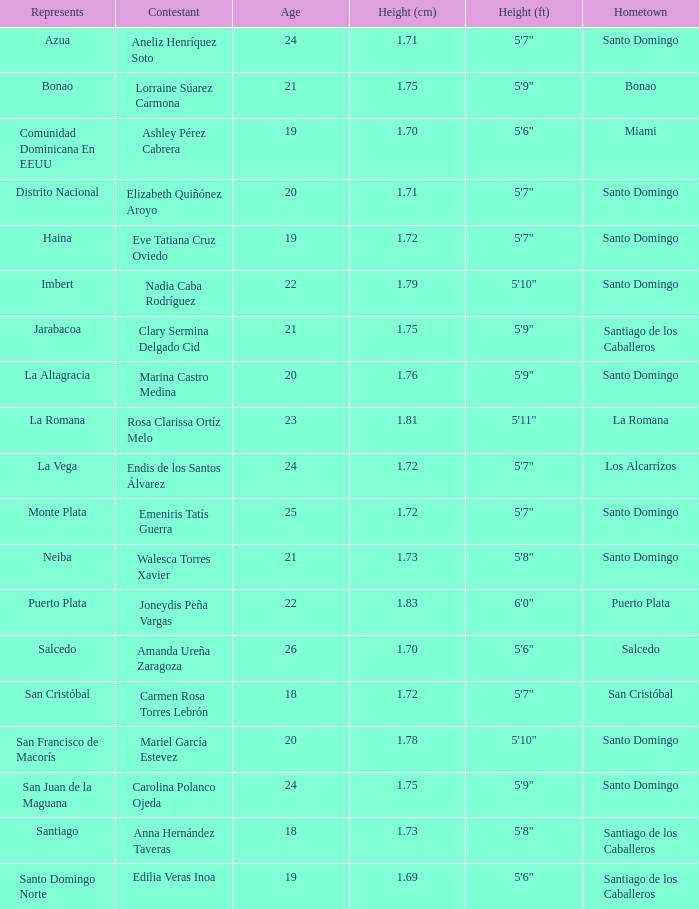Give me the full table as a dictionary. {'header': ['Represents', 'Contestant', 'Age', 'Height (cm)', 'Height (ft)', 'Hometown'], 'rows': [['Azua', 'Aneliz Henríquez Soto', '24', '1.71', '5\'7"', 'Santo Domingo'], ['Bonao', 'Lorraine Súarez Carmona', '21', '1.75', '5\'9"', 'Bonao'], ['Comunidad Dominicana En EEUU', 'Ashley Pérez Cabrera', '19', '1.70', '5\'6"', 'Miami'], ['Distrito Nacional', 'Elizabeth Quiñónez Aroyo', '20', '1.71', '5\'7"', 'Santo Domingo'], ['Haina', 'Eve Tatiana Cruz Oviedo', '19', '1.72', '5\'7"', 'Santo Domingo'], ['Imbert', 'Nadia Caba Rodríguez', '22', '1.79', '5\'10"', 'Santo Domingo'], ['Jarabacoa', 'Clary Sermina Delgado Cid', '21', '1.75', '5\'9"', 'Santiago de los Caballeros'], ['La Altagracia', 'Marina Castro Medina', '20', '1.76', '5\'9"', 'Santo Domingo'], ['La Romana', 'Rosa Clarissa Ortíz Melo', '23', '1.81', '5\'11"', 'La Romana'], ['La Vega', 'Endis de los Santos Álvarez', '24', '1.72', '5\'7"', 'Los Alcarrizos'], ['Monte Plata', 'Emeniris Tatís Guerra', '25', '1.72', '5\'7"', 'Santo Domingo'], ['Neiba', 'Walesca Torres Xavier', '21', '1.73', '5\'8"', 'Santo Domingo'], ['Puerto Plata', 'Joneydis Peña Vargas', '22', '1.83', '6\'0"', 'Puerto Plata'], ['Salcedo', 'Amanda Ureña Zaragoza', '26', '1.70', '5\'6"', 'Salcedo'], ['San Cristóbal', 'Carmen Rosa Torres Lebrón', '18', '1.72', '5\'7"', 'San Cristóbal'], ['San Francisco de Macorís', 'Mariel García Estevez', '20', '1.78', '5\'10"', 'Santo Domingo'], ['San Juan de la Maguana', 'Carolina Polanco Ojeda', '24', '1.75', '5\'9"', 'Santo Domingo'], ['Santiago', 'Anna Hernández Taveras', '18', '1.73', '5\'8"', 'Santiago de los Caballeros'], ['Santo Domingo Norte', 'Edilia Veras Inoa', '19', '1.69', '5\'6"', 'Santiago de los Caballeros']]} Name the most age 26.0. 